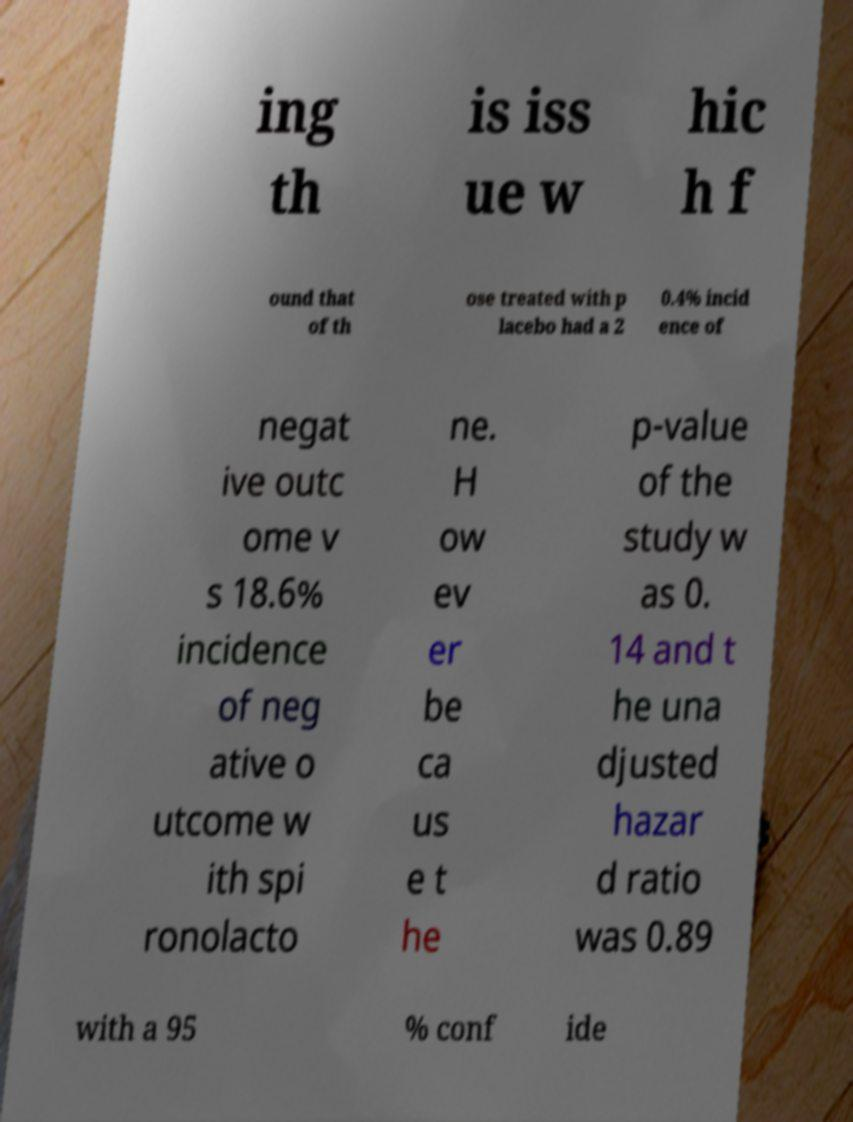Could you extract and type out the text from this image? ing th is iss ue w hic h f ound that of th ose treated with p lacebo had a 2 0.4% incid ence of negat ive outc ome v s 18.6% incidence of neg ative o utcome w ith spi ronolacto ne. H ow ev er be ca us e t he p-value of the study w as 0. 14 and t he una djusted hazar d ratio was 0.89 with a 95 % conf ide 